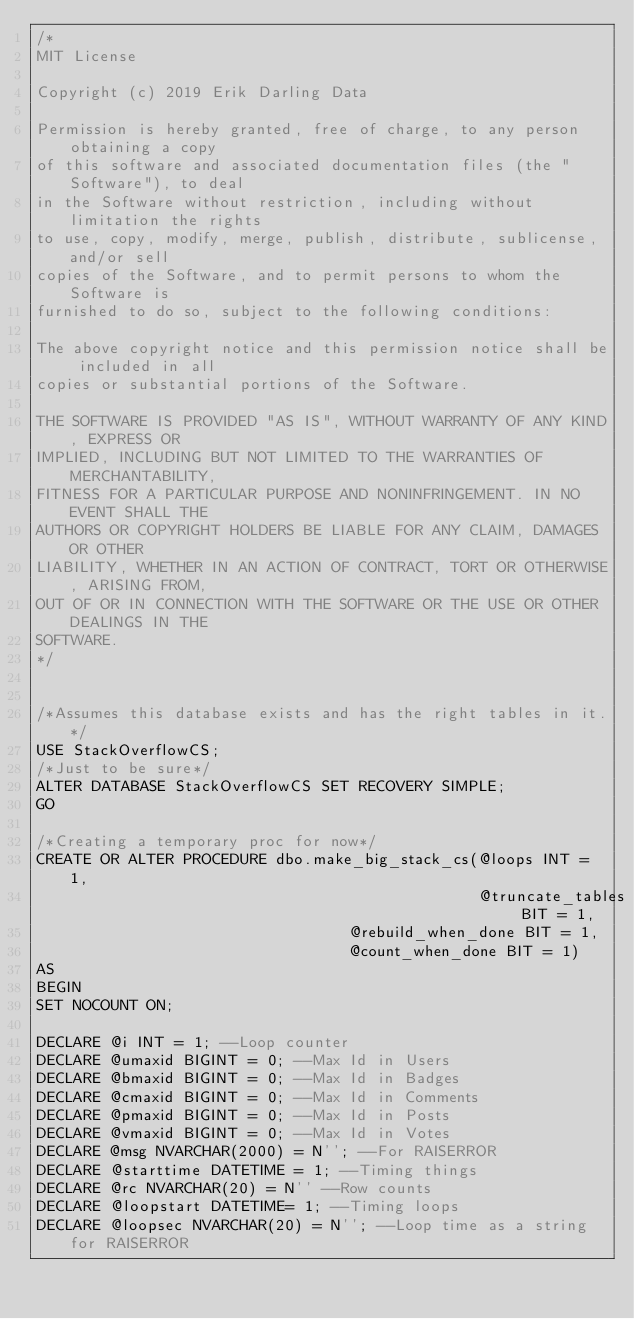Convert code to text. <code><loc_0><loc_0><loc_500><loc_500><_SQL_>/*
MIT License

Copyright (c) 2019 Erik Darling Data

Permission is hereby granted, free of charge, to any person obtaining a copy
of this software and associated documentation files (the "Software"), to deal
in the Software without restriction, including without limitation the rights
to use, copy, modify, merge, publish, distribute, sublicense, and/or sell
copies of the Software, and to permit persons to whom the Software is
furnished to do so, subject to the following conditions:

The above copyright notice and this permission notice shall be included in all
copies or substantial portions of the Software.

THE SOFTWARE IS PROVIDED "AS IS", WITHOUT WARRANTY OF ANY KIND, EXPRESS OR
IMPLIED, INCLUDING BUT NOT LIMITED TO THE WARRANTIES OF MERCHANTABILITY,
FITNESS FOR A PARTICULAR PURPOSE AND NONINFRINGEMENT. IN NO EVENT SHALL THE
AUTHORS OR COPYRIGHT HOLDERS BE LIABLE FOR ANY CLAIM, DAMAGES OR OTHER
LIABILITY, WHETHER IN AN ACTION OF CONTRACT, TORT OR OTHERWISE, ARISING FROM,
OUT OF OR IN CONNECTION WITH THE SOFTWARE OR THE USE OR OTHER DEALINGS IN THE
SOFTWARE.
*/


/*Assumes this database exists and has the right tables in it.*/
USE StackOverflowCS;
/*Just to be sure*/
ALTER DATABASE StackOverflowCS SET RECOVERY SIMPLE;
GO 

/*Creating a temporary proc for now*/
CREATE OR ALTER PROCEDURE dbo.make_big_stack_cs(@loops INT = 1,
                                                @truncate_tables BIT = 1,
							                    @rebuild_when_done BIT = 1,
							                    @count_when_done BIT = 1)
AS 
BEGIN
SET NOCOUNT ON;

DECLARE @i INT = 1; --Loop counter
DECLARE @umaxid BIGINT = 0; --Max Id in Users
DECLARE @bmaxid BIGINT = 0; --Max Id in Badges
DECLARE @cmaxid BIGINT = 0; --Max Id in Comments
DECLARE @pmaxid BIGINT = 0; --Max Id in Posts
DECLARE @vmaxid BIGINT = 0; --Max Id in Votes
DECLARE @msg NVARCHAR(2000) = N''; --For RAISERROR
DECLARE @starttime DATETIME = 1; --Timing things
DECLARE @rc NVARCHAR(20) = N'' --Row counts
DECLARE @loopstart DATETIME= 1; --Timing loops
DECLARE @loopsec NVARCHAR(20) = N''; --Loop time as a string for RAISERROR</code> 